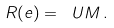<formula> <loc_0><loc_0><loc_500><loc_500>R ( e ) = \ U M \, .</formula> 